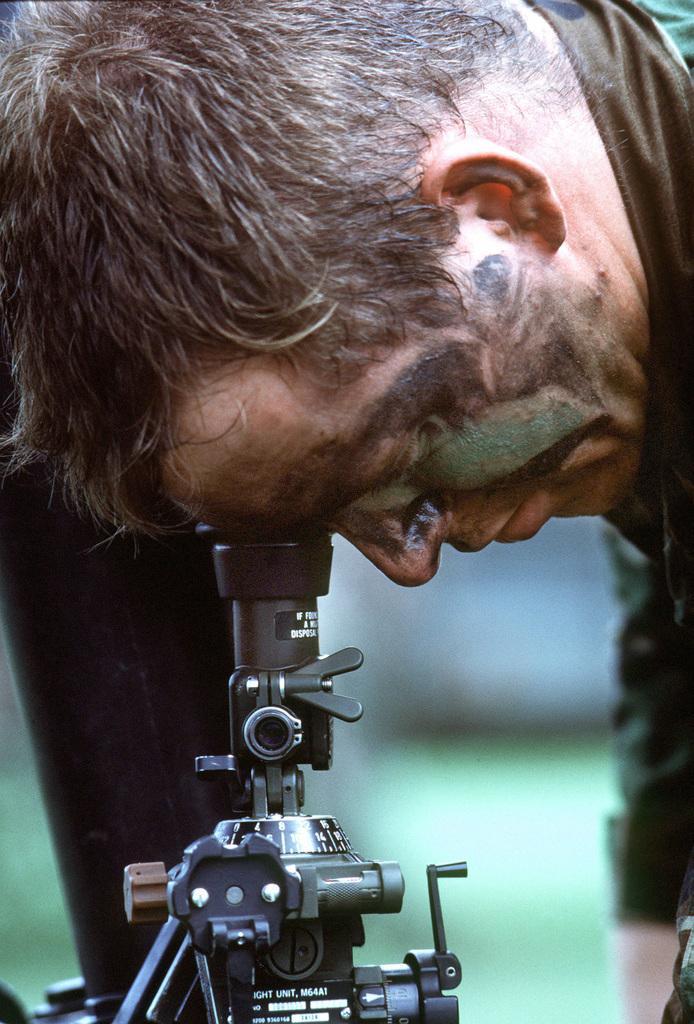In one or two sentences, can you explain what this image depicts? In this image I can see a man bending and watching through a microscope. The background is blurred. 